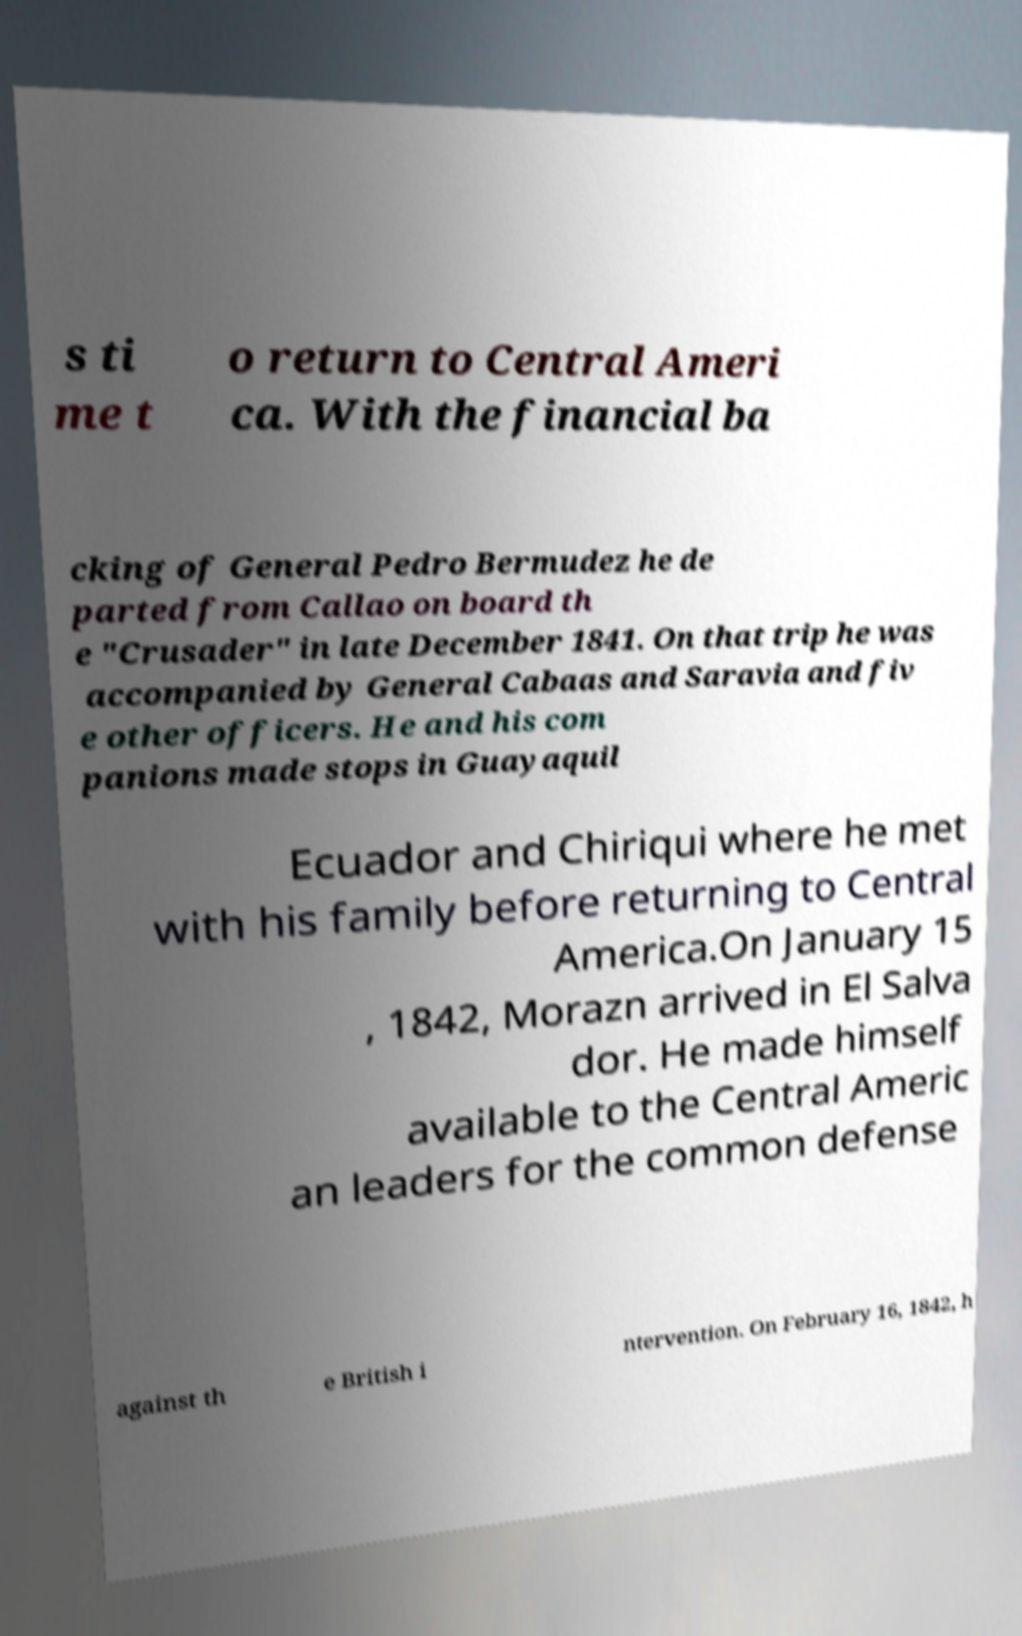I need the written content from this picture converted into text. Can you do that? s ti me t o return to Central Ameri ca. With the financial ba cking of General Pedro Bermudez he de parted from Callao on board th e "Crusader" in late December 1841. On that trip he was accompanied by General Cabaas and Saravia and fiv e other officers. He and his com panions made stops in Guayaquil Ecuador and Chiriqui where he met with his family before returning to Central America.On January 15 , 1842, Morazn arrived in El Salva dor. He made himself available to the Central Americ an leaders for the common defense against th e British i ntervention. On February 16, 1842, h 